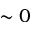Convert formula to latex. <formula><loc_0><loc_0><loc_500><loc_500>\sim 0</formula> 